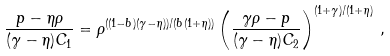<formula> <loc_0><loc_0><loc_500><loc_500>\frac { p - \eta \rho } { ( \gamma - \eta ) C _ { 1 } } = \rho ^ { ( ( 1 - b ) ( \gamma - \eta ) ) / ( b ( 1 + \eta ) ) } \left ( \frac { \gamma \rho - p } { ( \gamma - \eta ) C _ { 2 } } \right ) ^ { ( 1 + \gamma ) / ( 1 + \eta ) } \, ,</formula> 